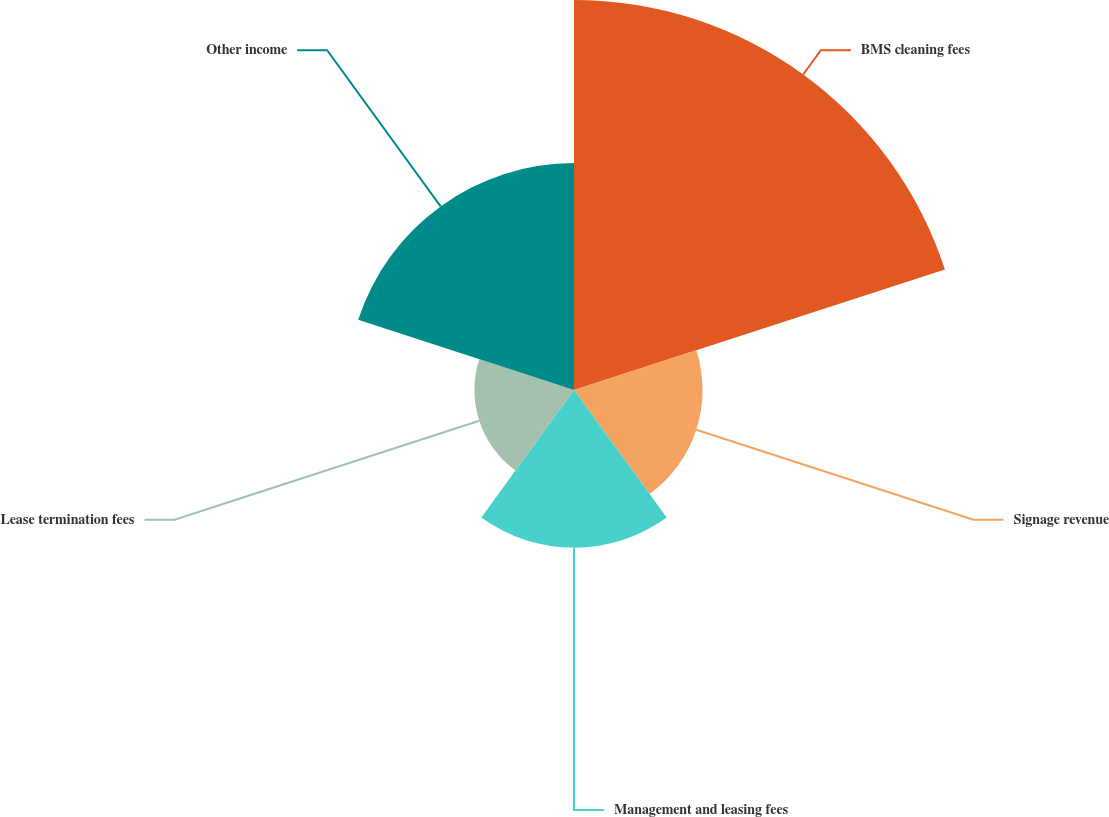<chart> <loc_0><loc_0><loc_500><loc_500><pie_chart><fcel>BMS cleaning fees<fcel>Signage revenue<fcel>Management and leasing fees<fcel>Lease termination fees<fcel>Other income<nl><fcel>38.89%<fcel>12.82%<fcel>15.72%<fcel>9.93%<fcel>22.63%<nl></chart> 